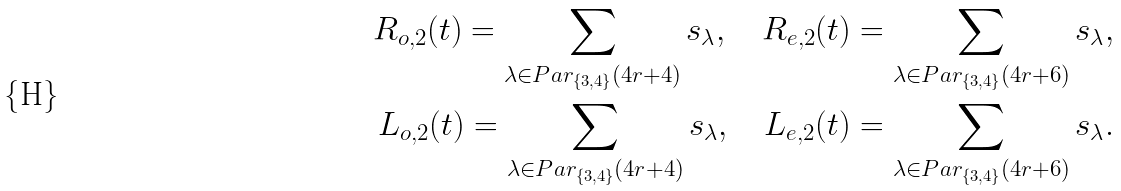Convert formula to latex. <formula><loc_0><loc_0><loc_500><loc_500>R _ { o , 2 } ( t ) = \sum _ { \lambda \in P a r _ { \{ 3 , 4 \} } ( 4 r + 4 ) } s _ { \lambda } , \quad R _ { e , 2 } ( t ) = \sum _ { \lambda \in P a r _ { \{ 3 , 4 \} } ( 4 r + 6 ) } s _ { \lambda } , \\ L _ { o , 2 } ( t ) = \sum _ { \lambda \in P a r _ { \{ 3 , 4 \} } ( 4 r + 4 ) } s _ { \lambda } , \quad L _ { e , 2 } ( t ) = \sum _ { \lambda \in P a r _ { \{ 3 , 4 \} } ( 4 r + 6 ) } s _ { \lambda } .</formula> 